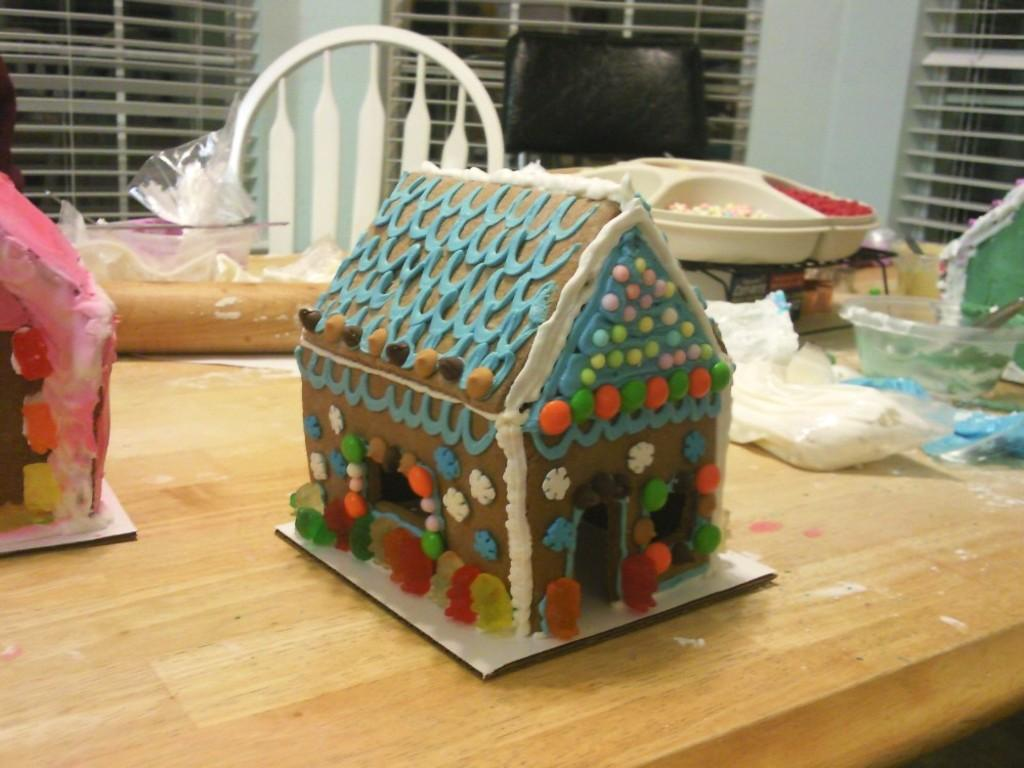What type of cakes are shown in the image? There are house cakes in the image. What is located on the table in the image? There is a bowl and other objects on a brown table in the image. What can be used for cleaning or wiping in the image? Tissues are present in the image for cleaning or wiping. What is visible in the background of the image? There are windows and a wall visible in the background. What type of crime is being committed in the image? There is no crime being committed in the image; it features house cakes, a bowl, tissues, and a table. What kind of worm can be seen crawling on the table in the image? There are no worms present in the image; it only features house cakes, a bowl, tissues, and a table. 